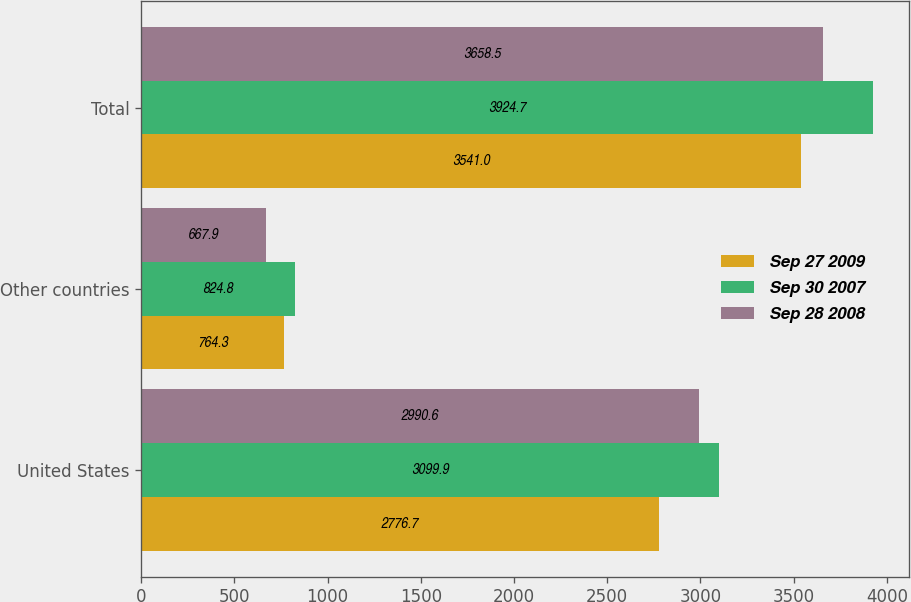<chart> <loc_0><loc_0><loc_500><loc_500><stacked_bar_chart><ecel><fcel>United States<fcel>Other countries<fcel>Total<nl><fcel>Sep 27 2009<fcel>2776.7<fcel>764.3<fcel>3541<nl><fcel>Sep 30 2007<fcel>3099.9<fcel>824.8<fcel>3924.7<nl><fcel>Sep 28 2008<fcel>2990.6<fcel>667.9<fcel>3658.5<nl></chart> 